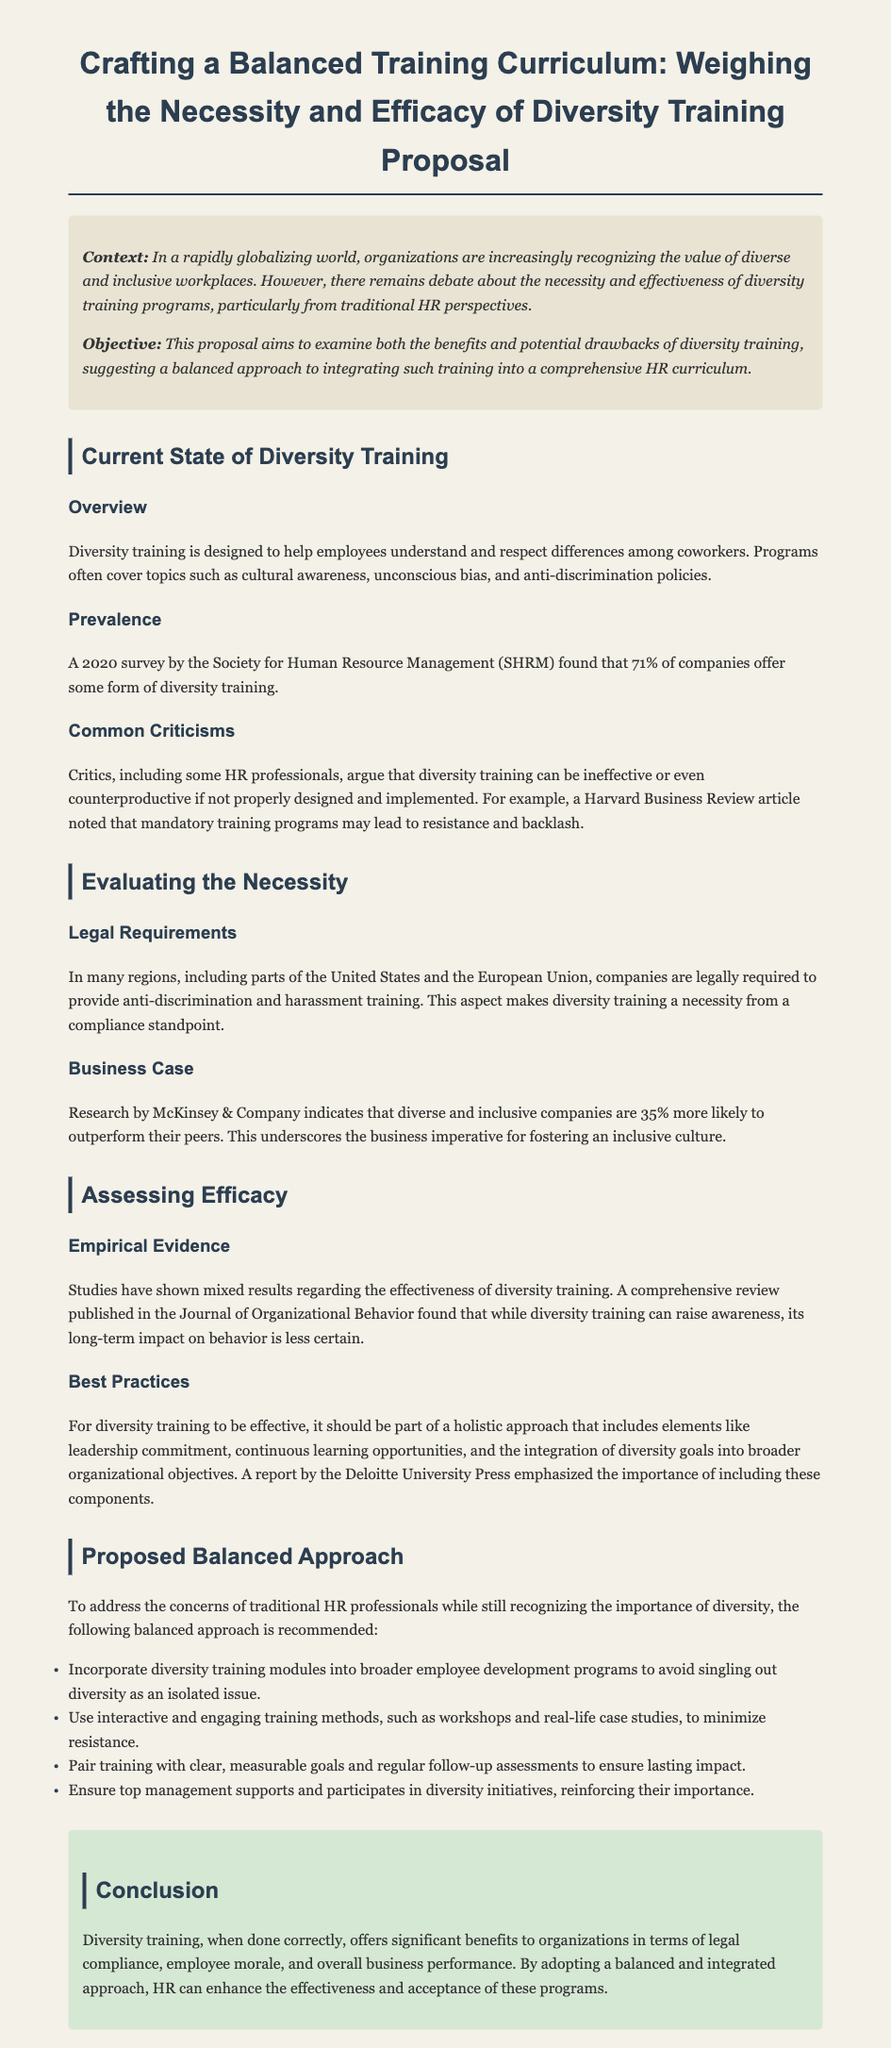What is the title of the proposal? The title of the proposal is mentioned at the top as "Crafting a Balanced Training Curriculum: Weighing the Necessity and Efficacy of Diversity Training Proposal."
Answer: Crafting a Balanced Training Curriculum: Weighing the Necessity and Efficacy of Diversity Training Proposal What percentage of companies offer diversity training? A 2020 survey by the Society for Human Resource Management found that 71% of companies offer some form of diversity training.
Answer: 71% What is one common criticism of diversity training? Critics argue that diversity training can be ineffective or even counterproductive if not properly designed and implemented.
Answer: Ineffective What does the McKinsey & Company research indicate? Research by McKinsey & Company indicates that diverse and inclusive companies are 35% more likely to outperform their peers.
Answer: 35% What is suggested for effective diversity training? It should be part of a holistic approach that includes elements like leadership commitment and continuous learning opportunities.
Answer: Holistic approach What is a proposed method to avoid resistance in diversity training? Use interactive and engaging training methods, such as workshops and real-life case studies, to minimize resistance.
Answer: Interactive methods What should diversity training be paired with for lasting impact? Pair training with clear, measurable goals and regular follow-up assessments to ensure lasting impact.
Answer: Measurable goals What is a legal requirement for diversity training in many regions? Many regions require companies to provide anti-discrimination and harassment training.
Answer: Anti-discrimination training What is the conclusion about diversity training? Diversity training, when done correctly, offers significant benefits to organizations in terms of legal compliance, employee morale, and overall business performance.
Answer: Significant benefits 